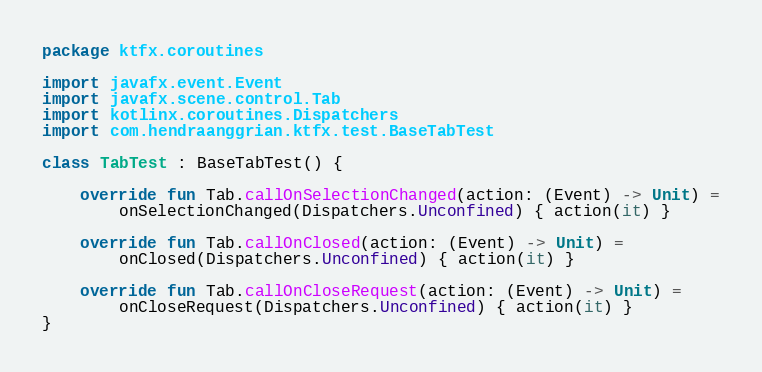Convert code to text. <code><loc_0><loc_0><loc_500><loc_500><_Kotlin_>package ktfx.coroutines

import javafx.event.Event
import javafx.scene.control.Tab
import kotlinx.coroutines.Dispatchers
import com.hendraanggrian.ktfx.test.BaseTabTest

class TabTest : BaseTabTest() {

    override fun Tab.callOnSelectionChanged(action: (Event) -> Unit) =
        onSelectionChanged(Dispatchers.Unconfined) { action(it) }

    override fun Tab.callOnClosed(action: (Event) -> Unit) =
        onClosed(Dispatchers.Unconfined) { action(it) }

    override fun Tab.callOnCloseRequest(action: (Event) -> Unit) =
        onCloseRequest(Dispatchers.Unconfined) { action(it) }
}</code> 